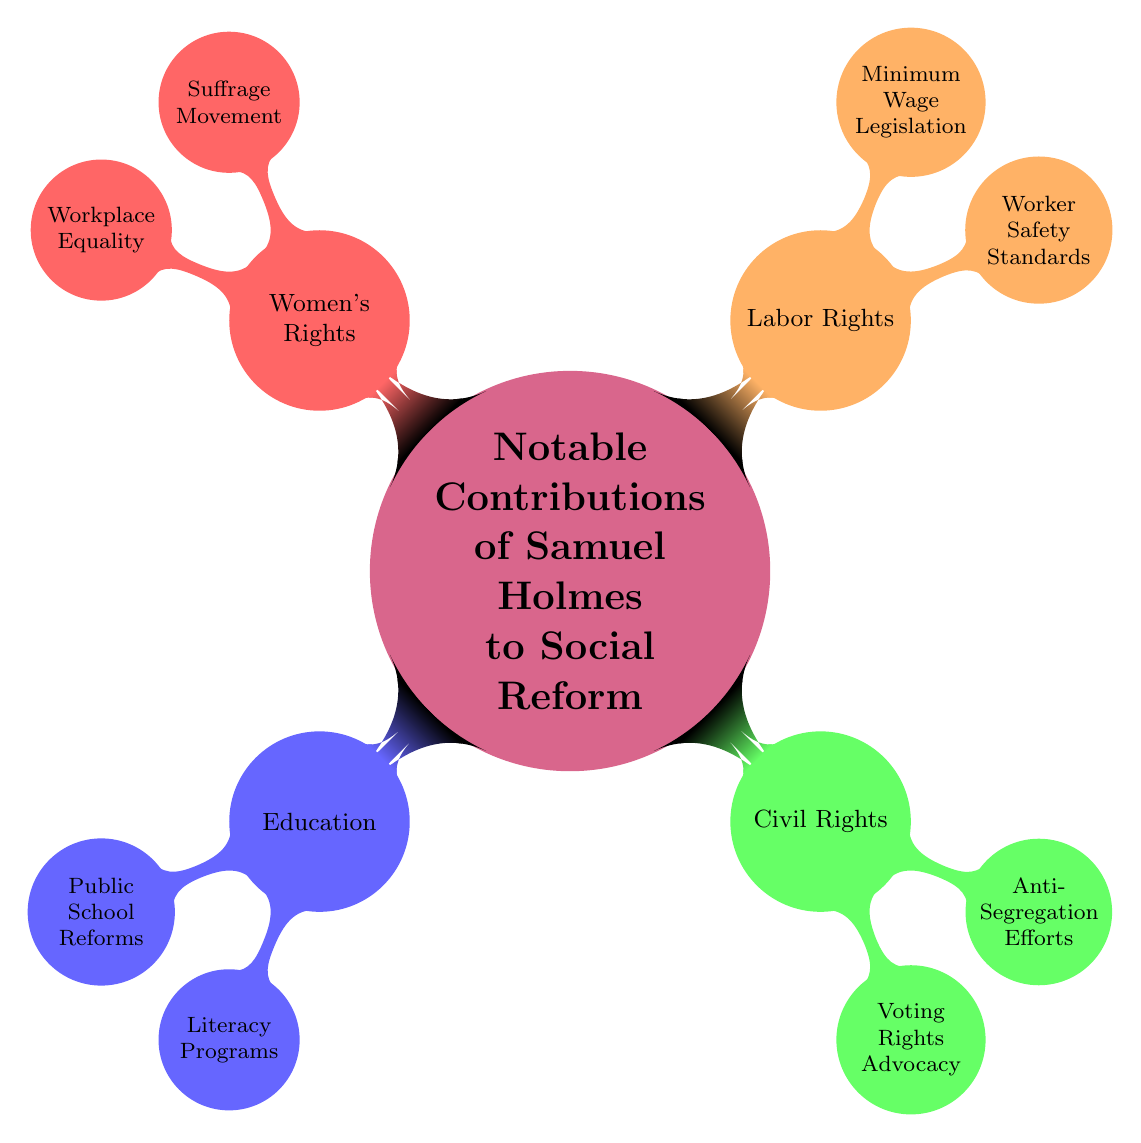What are the two main categories under Labor Rights? The diagram shows two branches under the Labor Rights category: Worker Safety Standards and Minimum Wage Legislation, representing key contributions by Samuel Holmes in this area.
Answer: Worker Safety Standards, Minimum Wage Legislation How many total categories are present in the diagram? Counting the main branches includes Education, Civil Rights, Labor Rights, and Women's Rights, which totals four categories in the diagram.
Answer: 4 Which social reform category includes the Suffrage Movement? The Suffrage Movement is listed under the Women's Rights category in the diagram, showing Samuel Holmes's involvement in advocating for women's voting rights.
Answer: Women's Rights What did Samuel Holmes advocate for regarding African American voting rights? The diagram indicates that Samuel Holmes engaged in Voting Rights Advocacy, specifically focused on fighting for African American voting rights during the Reconstruction era.
Answer: Voting Rights Advocacy What is the connection between Public School Reforms and Literacy Programs in the diagram? Both Public School Reforms and Literacy Programs are nodes under the Education category, illustrating that Samuel Holmes worked towards enhancing education as part of his social reform efforts.
Answer: Education What is one of the notable contributions related to workplace equality? The diagram highlights Workplace Equality as one of Samuel Holmes's efforts, where he advocated for equal pay for women in the workforce during the early 1900s.
Answer: Equal pay for women Which category has an effort focused on anti-segregation? The effort focused on anti-segregation is found under the Civil Rights category, where it specifies work against racial segregation laws in the Southern United States.
Answer: Civil Rights In which decade did Samuel Holmes push for improved safety regulations in coal mines? The diagram specifies that Samuel Holmes pushed for improved safety regulations in coal mines during the 1920s, indicating the timeframe of his labor rights advocacy.
Answer: 1920s What does the category of Women's Rights in the diagram encompass? The Women's Rights category includes the Suffrage Movement and Workplace Equality, reflecting Samuel Holmes's contributions to advancing rights for women.
Answer: Suffrage Movement, Workplace Equality 